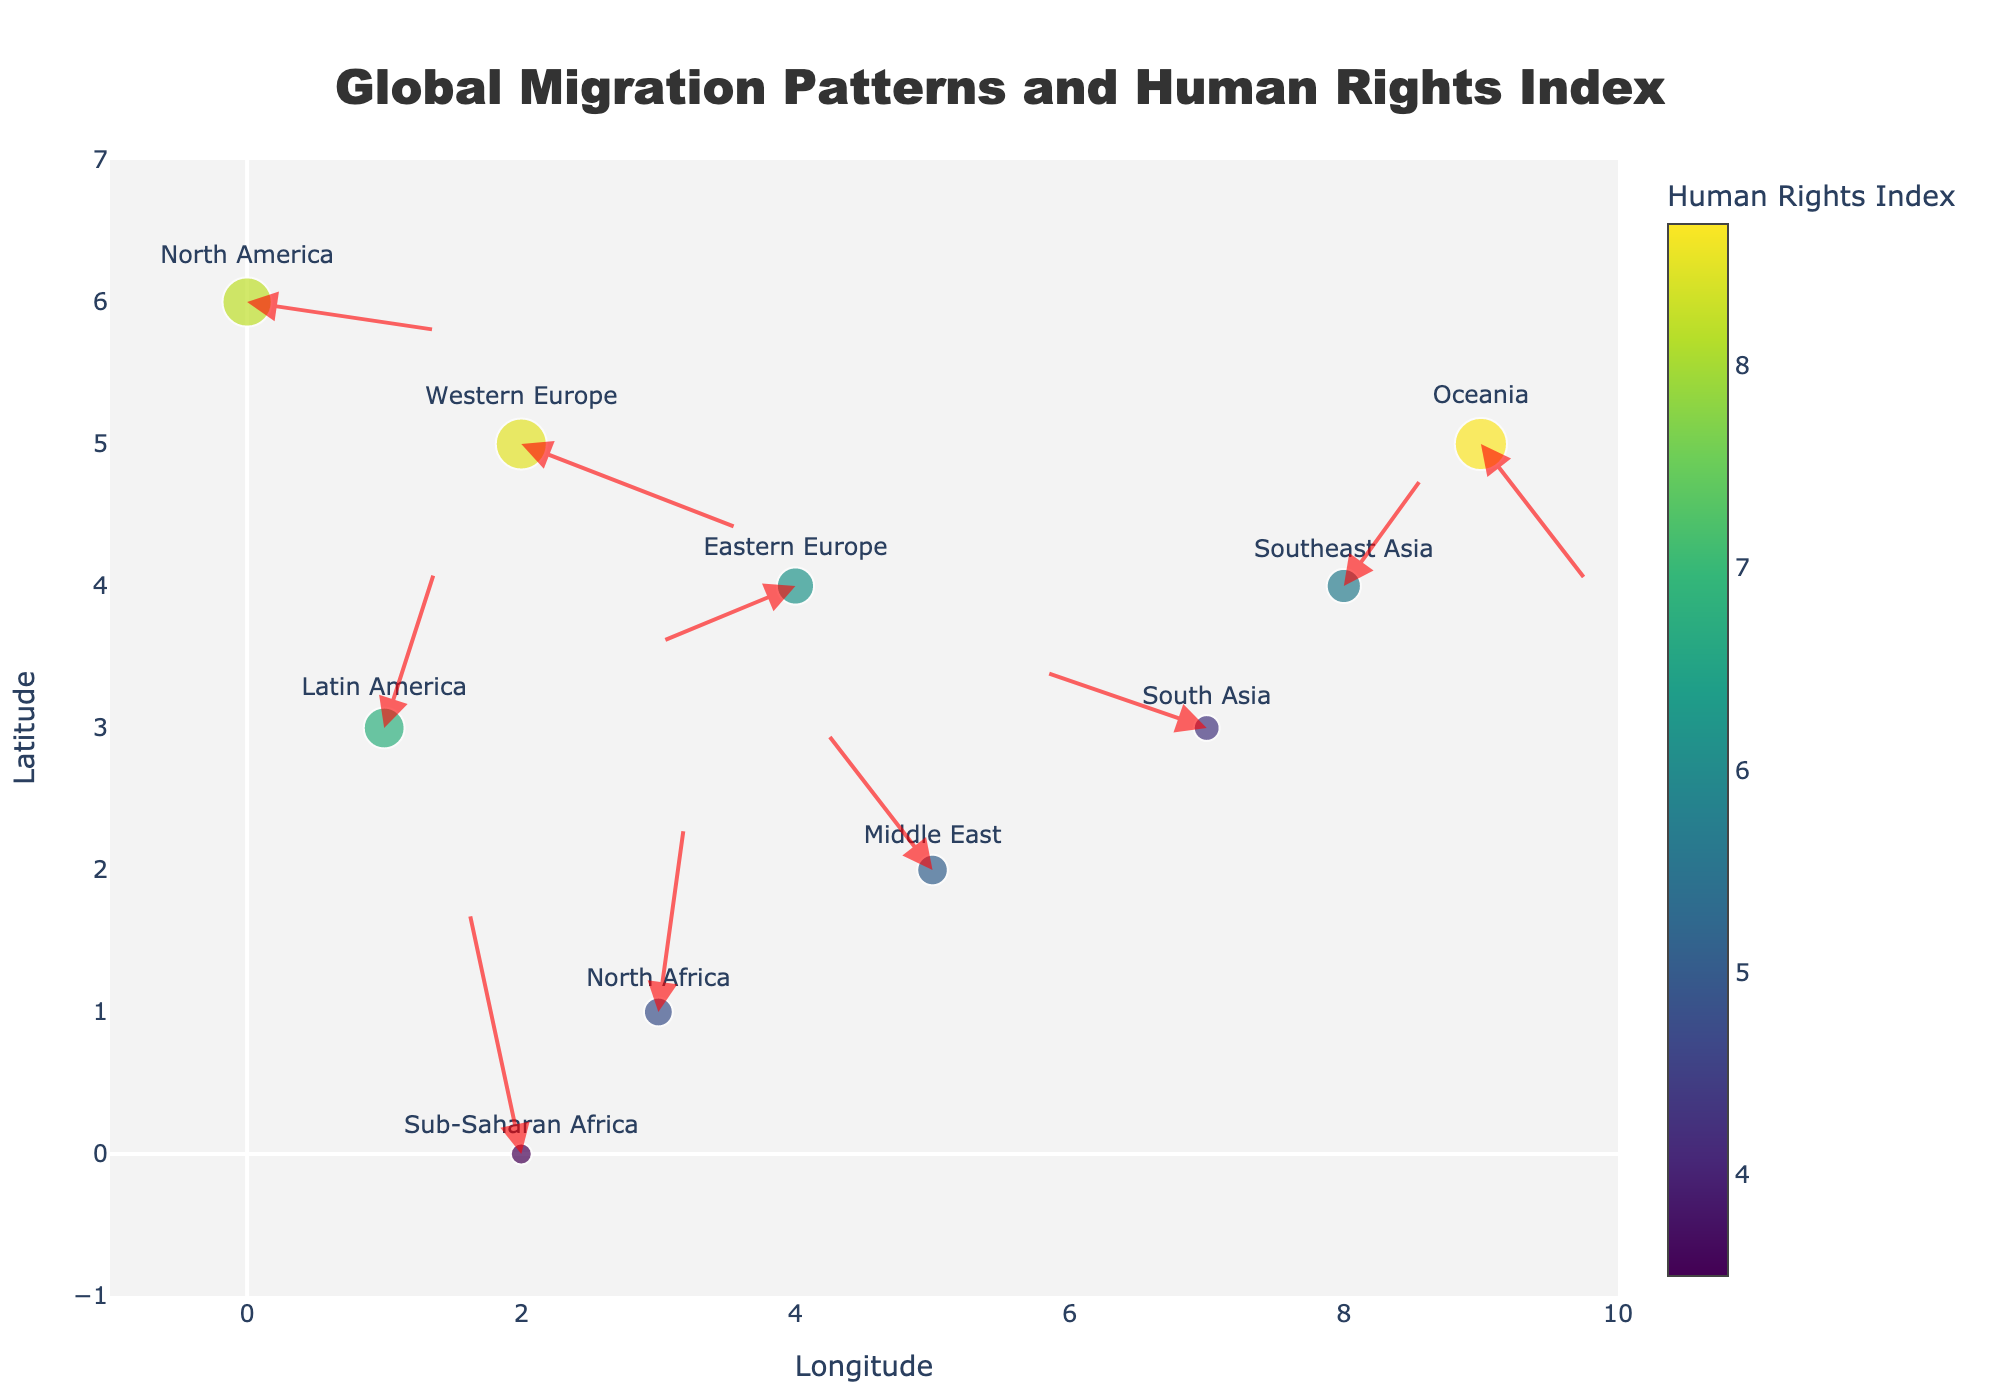How many regions are presented in the plot? Count the number of text labels (region names) represented by markers on the plot. You should see 10 different region names.
Answer: 10 Which region has the highest Human Rights Index? Look at the marker sizes and the color scale, the largest and most brightly colored marker corresponds to the region with the highest Human Rights Index. The region is Oceania.
Answer: Oceania What is the title of the plot? The title can be found at the top of the plot. It reads "Global Migration Patterns and Human Rights Index".
Answer: Global Migration Patterns and Human Rights Index Which region has the largest incoming migration flow? Incoming migration flow is indicated by arrows pointing towards the region. Compare the lengths of the incoming arrows to determine the largest one. Sub-Saharan Africa has the largest arrow pointing towards it.
Answer: Sub-Saharan Africa How does the Human Rights Index of Sub-Saharan Africa compare to Western Europe? Identify the indices from the marker sizes and colors. Sub-Saharan Africa has a Human Rights Index of 3.5, while Western Europe has 8.5. Sub-Saharan Africa's index is significantly lower than Western Europe's.
Answer: Sub-Saharan Africa's index is lower Which regions have a negative X component in their migration flows? Locate regions whose arrows have negative X components. This means the arrow points to the left. Eastern Europe, Middle East, and South Asia have negative X migration components.
Answer: Eastern Europe, Middle East, South Asia Between North America and Latin America, which region has a positive Human Rights Index and larger marker? Compare the sizes and colors of the markers for North America and Latin America. Both have positive indices, but North America's marker is larger.
Answer: North America What could be inferred about a region with a small-sized marker and light color? Small-sized markers with lighter colors indicate a lower Human Rights Index. This suggests poorer human rights conditions. E.g., Sub-Saharan Africa.
Answer: Poorer human rights conditions Which region shows a migration flow towards the Western Europe? Identify migration arrows pointing towards Western Europe. Follow the arrows starting from their tails to their heads. No region's migration flow specifically targets Western Europe directly on the plot.
Answer: None Comparing Southeast Asia and Sub-Saharan Africa, which direction does each region's migration flow indicate mainly? Review the direction of arrows for each region. Southeast Asia’s arrow points slightly NE (towards +X and +Y), while Sub-Saharan Africa's arrow points mainly N (towards +Y).
Answer: Southeast Asia - NE, Sub-Saharan Africa - N 